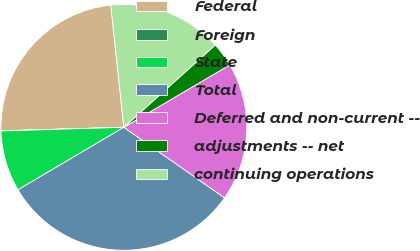<chart> <loc_0><loc_0><loc_500><loc_500><pie_chart><fcel>Federal<fcel>Foreign<fcel>State<fcel>Total<fcel>Deferred and non-current --<fcel>adjustments -- net<fcel>continuing operations<nl><fcel>23.77%<fcel>0.01%<fcel>8.02%<fcel>31.79%<fcel>18.21%<fcel>3.19%<fcel>15.03%<nl></chart> 